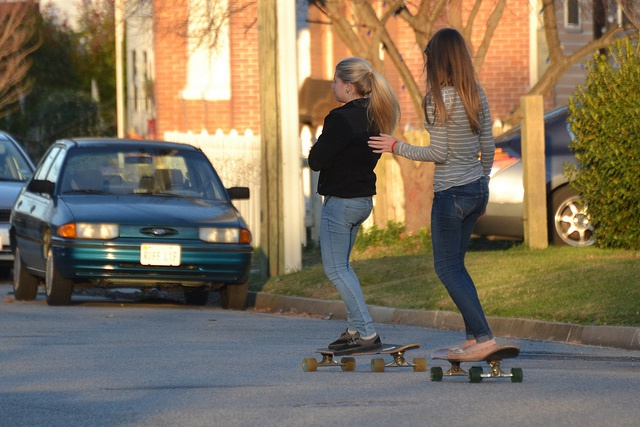Describe the objects in this image and their specific colors. I can see car in tan, black, blue, gray, and darkblue tones, people in tan, black, and gray tones, people in tan, black, and gray tones, car in tan, gray, olive, and ivory tones, and car in tan, gray, and black tones in this image. 